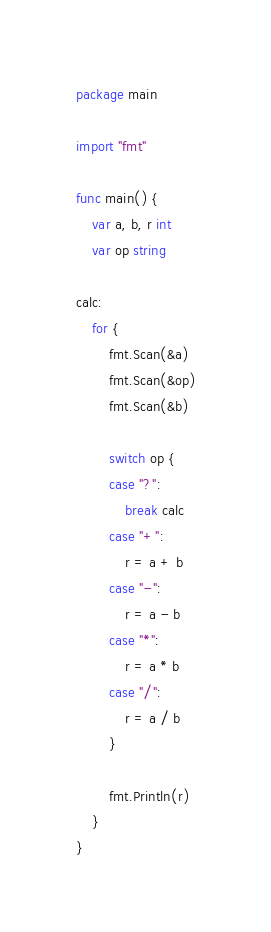<code> <loc_0><loc_0><loc_500><loc_500><_Go_>package main

import "fmt"

func main() {
	var a, b, r int
	var op string

calc:
	for {
		fmt.Scan(&a)
		fmt.Scan(&op)
		fmt.Scan(&b)

		switch op {
		case "?":
			break calc
		case "+":
			r = a + b
		case "-":
			r = a - b
		case "*":
			r = a * b
		case "/":
			r = a / b
		}

		fmt.Println(r)
	}
}

</code> 